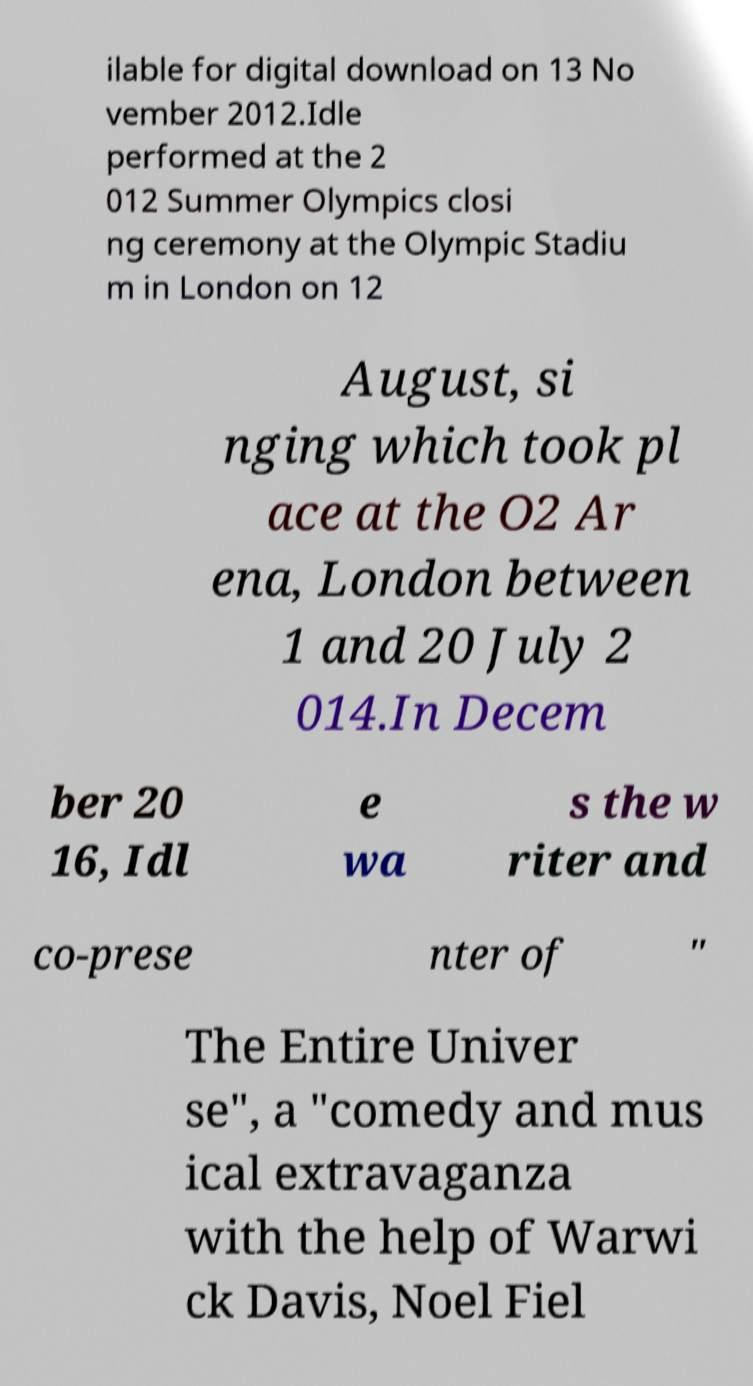There's text embedded in this image that I need extracted. Can you transcribe it verbatim? ilable for digital download on 13 No vember 2012.Idle performed at the 2 012 Summer Olympics closi ng ceremony at the Olympic Stadiu m in London on 12 August, si nging which took pl ace at the O2 Ar ena, London between 1 and 20 July 2 014.In Decem ber 20 16, Idl e wa s the w riter and co-prese nter of " The Entire Univer se", a "comedy and mus ical extravaganza with the help of Warwi ck Davis, Noel Fiel 